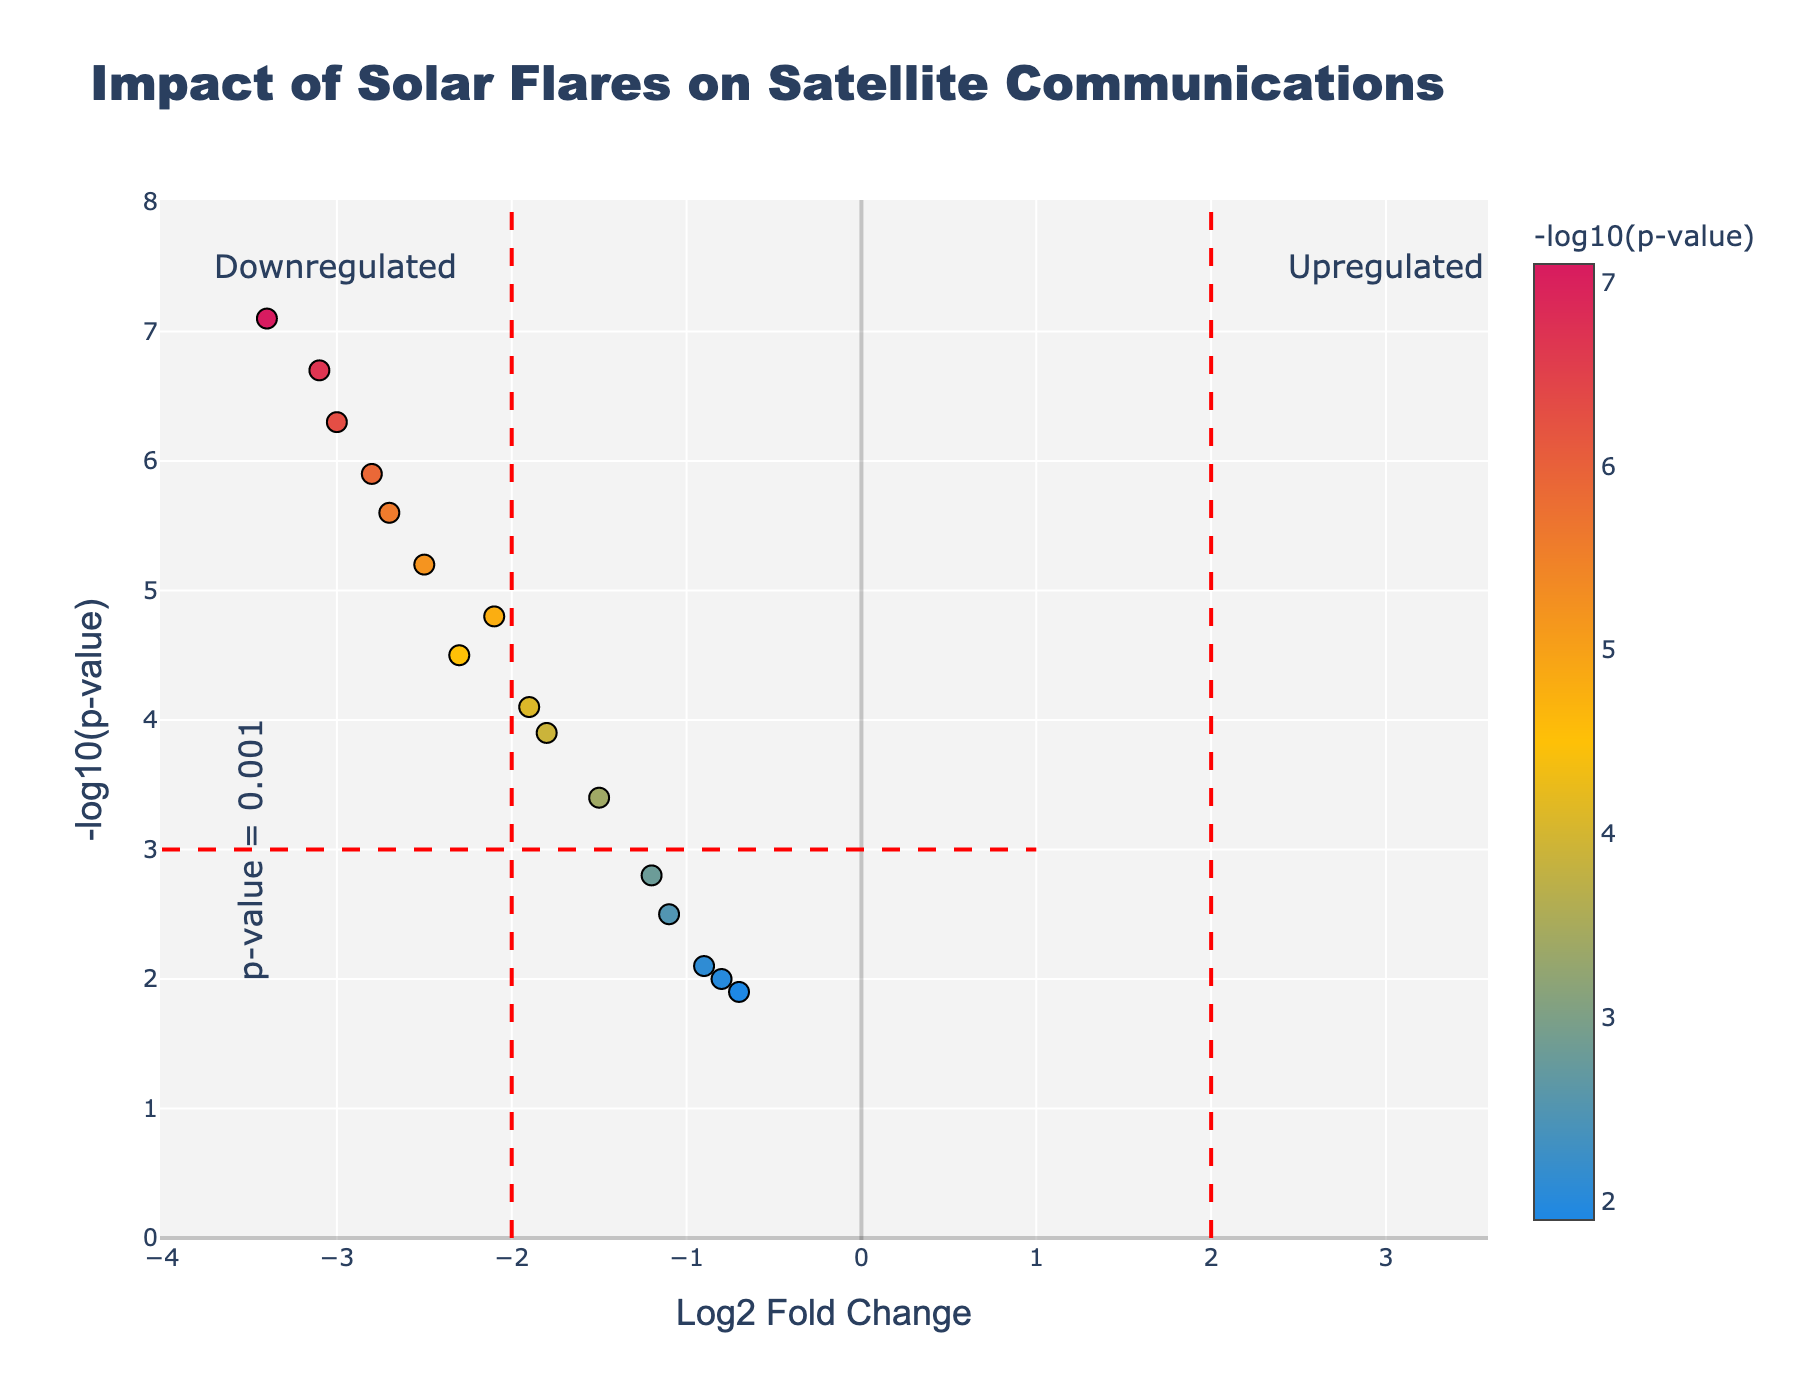What is the title of the plot? The title of the plot can be found at the top of the figure.
Answer: Impact of Solar Flares on Satellite Communications What is the x-axis labeled as? The x-axis label can be found at the bottom of the horizontal axis.
Answer: Log2 Fold Change How many data points have a negative log-fold change? Count the number of points on the left side of the vertical axis where x < 0.
Answer: 13 Which frequency band shows the most statistically significant disruption? Identify the point with the highest negative log p-value on the plot.
Answer: X-band (NASA TDRS) How is "Upregulated" denoted on the plot? Look for the annotation or label indicating "Upregulated" on the plot.
Answer: On the right side How many data points are both downregulated and statistically significant? Count the number of points to the left of x = -2 and above y = 3.
Answer: 6 Which satellite system in the L-band shows the highest statistical significance? Among L-band satellite systems, identify the one with the highest y-value.
Answer: Globalstar What is the log-fold change and negative log p-value for the satellite system GOES? Locate the data point labeled "GOES" and read its x and y values.
Answer: LogFoldChange = -3.0, NegativeLogPValue = 6.3 Compare the statistical significance of disruptions for C-band in Intelsat and SES. Which one is higher? Compare the y-values of the two points labeled as C-band for Intelsat and SES.
Answer: Intelsat Identify any two data points that are upregulated based on their log-fold change value. Look for points on the right side of the vertical axis (x > 0).
Answer: None 